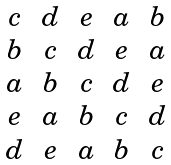<formula> <loc_0><loc_0><loc_500><loc_500>\begin{matrix} c & d & e & a & b \\ b & c & d & e & a \\ a & b & c & d & e \\ e & a & b & c & d \\ d & e & a & b & c \end{matrix}</formula> 